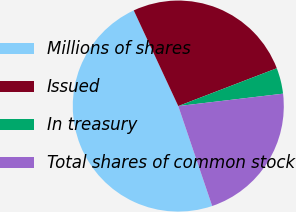<chart> <loc_0><loc_0><loc_500><loc_500><pie_chart><fcel>Millions of shares<fcel>Issued<fcel>In treasury<fcel>Total shares of common stock<nl><fcel>48.27%<fcel>26.1%<fcel>3.96%<fcel>21.67%<nl></chart> 